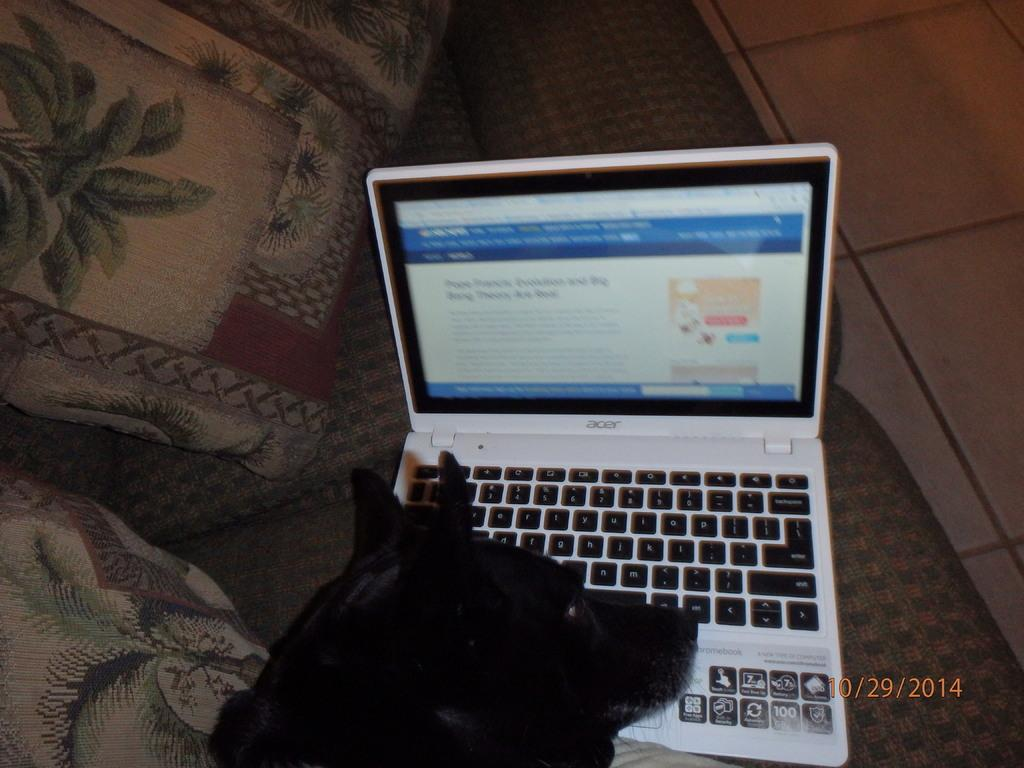<image>
Relay a brief, clear account of the picture shown. A lap top on which the number 100 can be seen at the bottom left 